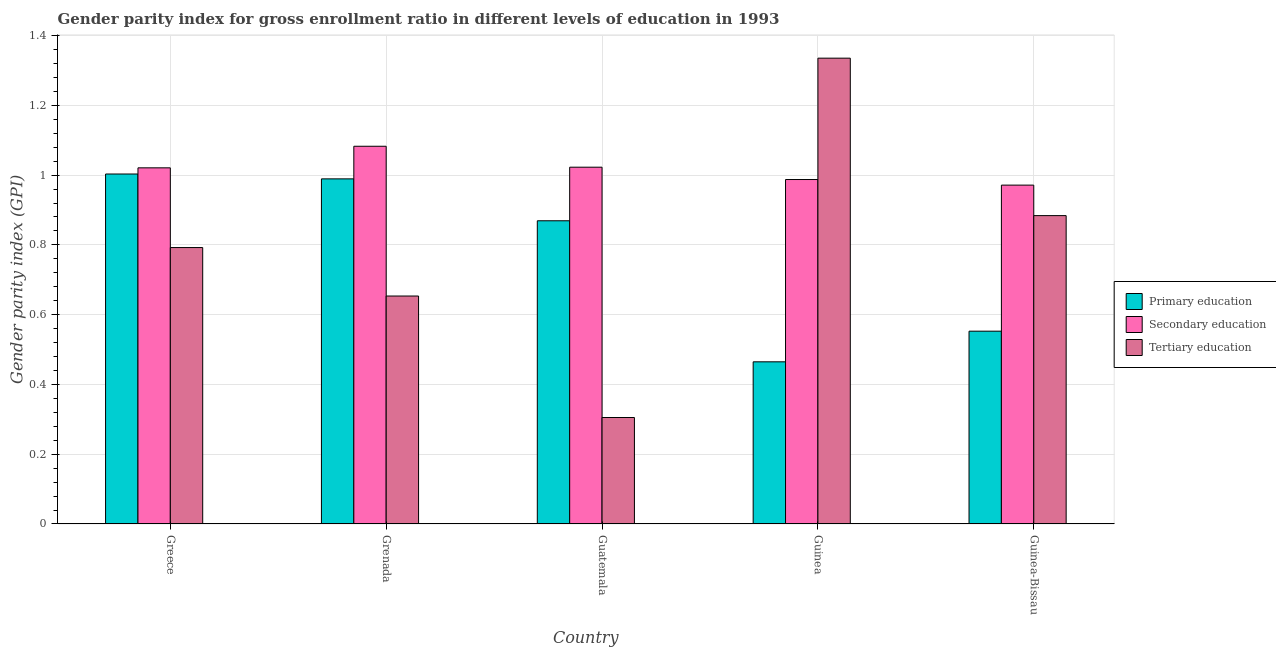Are the number of bars per tick equal to the number of legend labels?
Provide a succinct answer. Yes. Are the number of bars on each tick of the X-axis equal?
Ensure brevity in your answer.  Yes. How many bars are there on the 5th tick from the left?
Your answer should be compact. 3. How many bars are there on the 1st tick from the right?
Make the answer very short. 3. What is the gender parity index in tertiary education in Guinea?
Offer a very short reply. 1.34. Across all countries, what is the maximum gender parity index in tertiary education?
Offer a very short reply. 1.34. Across all countries, what is the minimum gender parity index in primary education?
Offer a terse response. 0.46. In which country was the gender parity index in secondary education maximum?
Provide a short and direct response. Grenada. In which country was the gender parity index in tertiary education minimum?
Offer a terse response. Guatemala. What is the total gender parity index in secondary education in the graph?
Ensure brevity in your answer.  5.08. What is the difference between the gender parity index in tertiary education in Grenada and that in Guinea-Bissau?
Your answer should be very brief. -0.23. What is the difference between the gender parity index in tertiary education in Guinea-Bissau and the gender parity index in primary education in Guinea?
Provide a short and direct response. 0.42. What is the average gender parity index in primary education per country?
Your answer should be compact. 0.78. What is the difference between the gender parity index in secondary education and gender parity index in primary education in Grenada?
Provide a short and direct response. 0.09. In how many countries, is the gender parity index in secondary education greater than 0.92 ?
Your response must be concise. 5. What is the ratio of the gender parity index in secondary education in Guatemala to that in Guinea-Bissau?
Provide a short and direct response. 1.05. Is the difference between the gender parity index in secondary education in Guatemala and Guinea-Bissau greater than the difference between the gender parity index in tertiary education in Guatemala and Guinea-Bissau?
Your answer should be compact. Yes. What is the difference between the highest and the second highest gender parity index in secondary education?
Your answer should be very brief. 0.06. What is the difference between the highest and the lowest gender parity index in secondary education?
Provide a short and direct response. 0.11. Is the sum of the gender parity index in tertiary education in Grenada and Guinea greater than the maximum gender parity index in secondary education across all countries?
Provide a short and direct response. Yes. What does the 2nd bar from the left in Guinea represents?
Ensure brevity in your answer.  Secondary education. What does the 1st bar from the right in Guinea represents?
Give a very brief answer. Tertiary education. Is it the case that in every country, the sum of the gender parity index in primary education and gender parity index in secondary education is greater than the gender parity index in tertiary education?
Provide a succinct answer. Yes. How many bars are there?
Offer a terse response. 15. How many countries are there in the graph?
Ensure brevity in your answer.  5. What is the difference between two consecutive major ticks on the Y-axis?
Provide a short and direct response. 0.2. Are the values on the major ticks of Y-axis written in scientific E-notation?
Your response must be concise. No. Does the graph contain grids?
Your answer should be very brief. Yes. How many legend labels are there?
Provide a succinct answer. 3. How are the legend labels stacked?
Provide a succinct answer. Vertical. What is the title of the graph?
Provide a short and direct response. Gender parity index for gross enrollment ratio in different levels of education in 1993. Does "Maunufacturing" appear as one of the legend labels in the graph?
Ensure brevity in your answer.  No. What is the label or title of the X-axis?
Your response must be concise. Country. What is the label or title of the Y-axis?
Provide a succinct answer. Gender parity index (GPI). What is the Gender parity index (GPI) of Primary education in Greece?
Your response must be concise. 1. What is the Gender parity index (GPI) in Secondary education in Greece?
Provide a short and direct response. 1.02. What is the Gender parity index (GPI) in Tertiary education in Greece?
Your response must be concise. 0.79. What is the Gender parity index (GPI) in Primary education in Grenada?
Provide a short and direct response. 0.99. What is the Gender parity index (GPI) in Secondary education in Grenada?
Your answer should be compact. 1.08. What is the Gender parity index (GPI) in Tertiary education in Grenada?
Offer a very short reply. 0.65. What is the Gender parity index (GPI) in Primary education in Guatemala?
Your answer should be very brief. 0.87. What is the Gender parity index (GPI) of Secondary education in Guatemala?
Provide a succinct answer. 1.02. What is the Gender parity index (GPI) of Tertiary education in Guatemala?
Keep it short and to the point. 0.31. What is the Gender parity index (GPI) of Primary education in Guinea?
Your answer should be very brief. 0.46. What is the Gender parity index (GPI) in Secondary education in Guinea?
Your answer should be very brief. 0.99. What is the Gender parity index (GPI) of Tertiary education in Guinea?
Give a very brief answer. 1.34. What is the Gender parity index (GPI) in Primary education in Guinea-Bissau?
Provide a short and direct response. 0.55. What is the Gender parity index (GPI) of Secondary education in Guinea-Bissau?
Offer a terse response. 0.97. What is the Gender parity index (GPI) in Tertiary education in Guinea-Bissau?
Provide a short and direct response. 0.88. Across all countries, what is the maximum Gender parity index (GPI) in Primary education?
Provide a succinct answer. 1. Across all countries, what is the maximum Gender parity index (GPI) in Secondary education?
Ensure brevity in your answer.  1.08. Across all countries, what is the maximum Gender parity index (GPI) of Tertiary education?
Offer a very short reply. 1.34. Across all countries, what is the minimum Gender parity index (GPI) of Primary education?
Ensure brevity in your answer.  0.46. Across all countries, what is the minimum Gender parity index (GPI) of Secondary education?
Provide a short and direct response. 0.97. Across all countries, what is the minimum Gender parity index (GPI) in Tertiary education?
Keep it short and to the point. 0.31. What is the total Gender parity index (GPI) of Primary education in the graph?
Your response must be concise. 3.88. What is the total Gender parity index (GPI) in Secondary education in the graph?
Ensure brevity in your answer.  5.08. What is the total Gender parity index (GPI) in Tertiary education in the graph?
Offer a very short reply. 3.97. What is the difference between the Gender parity index (GPI) of Primary education in Greece and that in Grenada?
Provide a short and direct response. 0.01. What is the difference between the Gender parity index (GPI) in Secondary education in Greece and that in Grenada?
Provide a succinct answer. -0.06. What is the difference between the Gender parity index (GPI) in Tertiary education in Greece and that in Grenada?
Keep it short and to the point. 0.14. What is the difference between the Gender parity index (GPI) of Primary education in Greece and that in Guatemala?
Make the answer very short. 0.13. What is the difference between the Gender parity index (GPI) in Secondary education in Greece and that in Guatemala?
Your response must be concise. -0. What is the difference between the Gender parity index (GPI) in Tertiary education in Greece and that in Guatemala?
Offer a very short reply. 0.49. What is the difference between the Gender parity index (GPI) in Primary education in Greece and that in Guinea?
Keep it short and to the point. 0.54. What is the difference between the Gender parity index (GPI) in Secondary education in Greece and that in Guinea?
Offer a terse response. 0.03. What is the difference between the Gender parity index (GPI) of Tertiary education in Greece and that in Guinea?
Your answer should be compact. -0.54. What is the difference between the Gender parity index (GPI) in Primary education in Greece and that in Guinea-Bissau?
Your response must be concise. 0.45. What is the difference between the Gender parity index (GPI) of Secondary education in Greece and that in Guinea-Bissau?
Keep it short and to the point. 0.05. What is the difference between the Gender parity index (GPI) of Tertiary education in Greece and that in Guinea-Bissau?
Your answer should be compact. -0.09. What is the difference between the Gender parity index (GPI) of Primary education in Grenada and that in Guatemala?
Make the answer very short. 0.12. What is the difference between the Gender parity index (GPI) in Tertiary education in Grenada and that in Guatemala?
Ensure brevity in your answer.  0.35. What is the difference between the Gender parity index (GPI) in Primary education in Grenada and that in Guinea?
Your response must be concise. 0.52. What is the difference between the Gender parity index (GPI) in Secondary education in Grenada and that in Guinea?
Provide a short and direct response. 0.1. What is the difference between the Gender parity index (GPI) of Tertiary education in Grenada and that in Guinea?
Your answer should be compact. -0.68. What is the difference between the Gender parity index (GPI) in Primary education in Grenada and that in Guinea-Bissau?
Your response must be concise. 0.44. What is the difference between the Gender parity index (GPI) in Secondary education in Grenada and that in Guinea-Bissau?
Make the answer very short. 0.11. What is the difference between the Gender parity index (GPI) in Tertiary education in Grenada and that in Guinea-Bissau?
Ensure brevity in your answer.  -0.23. What is the difference between the Gender parity index (GPI) of Primary education in Guatemala and that in Guinea?
Provide a short and direct response. 0.4. What is the difference between the Gender parity index (GPI) of Secondary education in Guatemala and that in Guinea?
Provide a short and direct response. 0.04. What is the difference between the Gender parity index (GPI) in Tertiary education in Guatemala and that in Guinea?
Offer a very short reply. -1.03. What is the difference between the Gender parity index (GPI) in Primary education in Guatemala and that in Guinea-Bissau?
Your answer should be very brief. 0.32. What is the difference between the Gender parity index (GPI) of Secondary education in Guatemala and that in Guinea-Bissau?
Your answer should be very brief. 0.05. What is the difference between the Gender parity index (GPI) in Tertiary education in Guatemala and that in Guinea-Bissau?
Give a very brief answer. -0.58. What is the difference between the Gender parity index (GPI) in Primary education in Guinea and that in Guinea-Bissau?
Ensure brevity in your answer.  -0.09. What is the difference between the Gender parity index (GPI) in Secondary education in Guinea and that in Guinea-Bissau?
Offer a very short reply. 0.02. What is the difference between the Gender parity index (GPI) of Tertiary education in Guinea and that in Guinea-Bissau?
Your answer should be very brief. 0.45. What is the difference between the Gender parity index (GPI) in Primary education in Greece and the Gender parity index (GPI) in Secondary education in Grenada?
Make the answer very short. -0.08. What is the difference between the Gender parity index (GPI) of Primary education in Greece and the Gender parity index (GPI) of Tertiary education in Grenada?
Make the answer very short. 0.35. What is the difference between the Gender parity index (GPI) of Secondary education in Greece and the Gender parity index (GPI) of Tertiary education in Grenada?
Your response must be concise. 0.37. What is the difference between the Gender parity index (GPI) of Primary education in Greece and the Gender parity index (GPI) of Secondary education in Guatemala?
Your answer should be very brief. -0.02. What is the difference between the Gender parity index (GPI) in Primary education in Greece and the Gender parity index (GPI) in Tertiary education in Guatemala?
Your answer should be compact. 0.7. What is the difference between the Gender parity index (GPI) of Secondary education in Greece and the Gender parity index (GPI) of Tertiary education in Guatemala?
Keep it short and to the point. 0.72. What is the difference between the Gender parity index (GPI) of Primary education in Greece and the Gender parity index (GPI) of Secondary education in Guinea?
Offer a very short reply. 0.02. What is the difference between the Gender parity index (GPI) in Primary education in Greece and the Gender parity index (GPI) in Tertiary education in Guinea?
Your response must be concise. -0.33. What is the difference between the Gender parity index (GPI) in Secondary education in Greece and the Gender parity index (GPI) in Tertiary education in Guinea?
Provide a succinct answer. -0.31. What is the difference between the Gender parity index (GPI) in Primary education in Greece and the Gender parity index (GPI) in Secondary education in Guinea-Bissau?
Provide a succinct answer. 0.03. What is the difference between the Gender parity index (GPI) of Primary education in Greece and the Gender parity index (GPI) of Tertiary education in Guinea-Bissau?
Your answer should be compact. 0.12. What is the difference between the Gender parity index (GPI) in Secondary education in Greece and the Gender parity index (GPI) in Tertiary education in Guinea-Bissau?
Your answer should be very brief. 0.14. What is the difference between the Gender parity index (GPI) in Primary education in Grenada and the Gender parity index (GPI) in Secondary education in Guatemala?
Offer a terse response. -0.03. What is the difference between the Gender parity index (GPI) in Primary education in Grenada and the Gender parity index (GPI) in Tertiary education in Guatemala?
Provide a short and direct response. 0.68. What is the difference between the Gender parity index (GPI) of Secondary education in Grenada and the Gender parity index (GPI) of Tertiary education in Guatemala?
Offer a terse response. 0.78. What is the difference between the Gender parity index (GPI) in Primary education in Grenada and the Gender parity index (GPI) in Secondary education in Guinea?
Keep it short and to the point. 0. What is the difference between the Gender parity index (GPI) of Primary education in Grenada and the Gender parity index (GPI) of Tertiary education in Guinea?
Provide a succinct answer. -0.35. What is the difference between the Gender parity index (GPI) in Secondary education in Grenada and the Gender parity index (GPI) in Tertiary education in Guinea?
Your answer should be very brief. -0.25. What is the difference between the Gender parity index (GPI) of Primary education in Grenada and the Gender parity index (GPI) of Secondary education in Guinea-Bissau?
Your response must be concise. 0.02. What is the difference between the Gender parity index (GPI) in Primary education in Grenada and the Gender parity index (GPI) in Tertiary education in Guinea-Bissau?
Make the answer very short. 0.11. What is the difference between the Gender parity index (GPI) in Secondary education in Grenada and the Gender parity index (GPI) in Tertiary education in Guinea-Bissau?
Keep it short and to the point. 0.2. What is the difference between the Gender parity index (GPI) of Primary education in Guatemala and the Gender parity index (GPI) of Secondary education in Guinea?
Give a very brief answer. -0.12. What is the difference between the Gender parity index (GPI) in Primary education in Guatemala and the Gender parity index (GPI) in Tertiary education in Guinea?
Offer a very short reply. -0.47. What is the difference between the Gender parity index (GPI) of Secondary education in Guatemala and the Gender parity index (GPI) of Tertiary education in Guinea?
Your answer should be very brief. -0.31. What is the difference between the Gender parity index (GPI) in Primary education in Guatemala and the Gender parity index (GPI) in Secondary education in Guinea-Bissau?
Ensure brevity in your answer.  -0.1. What is the difference between the Gender parity index (GPI) in Primary education in Guatemala and the Gender parity index (GPI) in Tertiary education in Guinea-Bissau?
Offer a terse response. -0.01. What is the difference between the Gender parity index (GPI) of Secondary education in Guatemala and the Gender parity index (GPI) of Tertiary education in Guinea-Bissau?
Your answer should be very brief. 0.14. What is the difference between the Gender parity index (GPI) of Primary education in Guinea and the Gender parity index (GPI) of Secondary education in Guinea-Bissau?
Make the answer very short. -0.51. What is the difference between the Gender parity index (GPI) of Primary education in Guinea and the Gender parity index (GPI) of Tertiary education in Guinea-Bissau?
Keep it short and to the point. -0.42. What is the difference between the Gender parity index (GPI) in Secondary education in Guinea and the Gender parity index (GPI) in Tertiary education in Guinea-Bissau?
Make the answer very short. 0.1. What is the average Gender parity index (GPI) in Primary education per country?
Offer a very short reply. 0.78. What is the average Gender parity index (GPI) in Tertiary education per country?
Provide a succinct answer. 0.79. What is the difference between the Gender parity index (GPI) in Primary education and Gender parity index (GPI) in Secondary education in Greece?
Provide a succinct answer. -0.02. What is the difference between the Gender parity index (GPI) in Primary education and Gender parity index (GPI) in Tertiary education in Greece?
Your answer should be compact. 0.21. What is the difference between the Gender parity index (GPI) of Secondary education and Gender parity index (GPI) of Tertiary education in Greece?
Your response must be concise. 0.23. What is the difference between the Gender parity index (GPI) of Primary education and Gender parity index (GPI) of Secondary education in Grenada?
Provide a succinct answer. -0.09. What is the difference between the Gender parity index (GPI) of Primary education and Gender parity index (GPI) of Tertiary education in Grenada?
Your response must be concise. 0.34. What is the difference between the Gender parity index (GPI) in Secondary education and Gender parity index (GPI) in Tertiary education in Grenada?
Ensure brevity in your answer.  0.43. What is the difference between the Gender parity index (GPI) in Primary education and Gender parity index (GPI) in Secondary education in Guatemala?
Provide a succinct answer. -0.15. What is the difference between the Gender parity index (GPI) in Primary education and Gender parity index (GPI) in Tertiary education in Guatemala?
Ensure brevity in your answer.  0.56. What is the difference between the Gender parity index (GPI) in Secondary education and Gender parity index (GPI) in Tertiary education in Guatemala?
Your answer should be very brief. 0.72. What is the difference between the Gender parity index (GPI) of Primary education and Gender parity index (GPI) of Secondary education in Guinea?
Your answer should be compact. -0.52. What is the difference between the Gender parity index (GPI) of Primary education and Gender parity index (GPI) of Tertiary education in Guinea?
Your response must be concise. -0.87. What is the difference between the Gender parity index (GPI) of Secondary education and Gender parity index (GPI) of Tertiary education in Guinea?
Offer a terse response. -0.35. What is the difference between the Gender parity index (GPI) of Primary education and Gender parity index (GPI) of Secondary education in Guinea-Bissau?
Your response must be concise. -0.42. What is the difference between the Gender parity index (GPI) of Primary education and Gender parity index (GPI) of Tertiary education in Guinea-Bissau?
Your answer should be compact. -0.33. What is the difference between the Gender parity index (GPI) of Secondary education and Gender parity index (GPI) of Tertiary education in Guinea-Bissau?
Make the answer very short. 0.09. What is the ratio of the Gender parity index (GPI) in Primary education in Greece to that in Grenada?
Offer a terse response. 1.01. What is the ratio of the Gender parity index (GPI) in Secondary education in Greece to that in Grenada?
Ensure brevity in your answer.  0.94. What is the ratio of the Gender parity index (GPI) of Tertiary education in Greece to that in Grenada?
Ensure brevity in your answer.  1.21. What is the ratio of the Gender parity index (GPI) in Primary education in Greece to that in Guatemala?
Offer a very short reply. 1.15. What is the ratio of the Gender parity index (GPI) of Tertiary education in Greece to that in Guatemala?
Your answer should be compact. 2.6. What is the ratio of the Gender parity index (GPI) in Primary education in Greece to that in Guinea?
Provide a short and direct response. 2.16. What is the ratio of the Gender parity index (GPI) of Secondary education in Greece to that in Guinea?
Your answer should be very brief. 1.03. What is the ratio of the Gender parity index (GPI) of Tertiary education in Greece to that in Guinea?
Provide a succinct answer. 0.59. What is the ratio of the Gender parity index (GPI) of Primary education in Greece to that in Guinea-Bissau?
Your answer should be very brief. 1.82. What is the ratio of the Gender parity index (GPI) of Secondary education in Greece to that in Guinea-Bissau?
Keep it short and to the point. 1.05. What is the ratio of the Gender parity index (GPI) in Tertiary education in Greece to that in Guinea-Bissau?
Your answer should be very brief. 0.9. What is the ratio of the Gender parity index (GPI) of Primary education in Grenada to that in Guatemala?
Your answer should be compact. 1.14. What is the ratio of the Gender parity index (GPI) of Secondary education in Grenada to that in Guatemala?
Keep it short and to the point. 1.06. What is the ratio of the Gender parity index (GPI) of Tertiary education in Grenada to that in Guatemala?
Keep it short and to the point. 2.14. What is the ratio of the Gender parity index (GPI) in Primary education in Grenada to that in Guinea?
Your answer should be very brief. 2.13. What is the ratio of the Gender parity index (GPI) in Secondary education in Grenada to that in Guinea?
Your response must be concise. 1.1. What is the ratio of the Gender parity index (GPI) of Tertiary education in Grenada to that in Guinea?
Offer a very short reply. 0.49. What is the ratio of the Gender parity index (GPI) of Primary education in Grenada to that in Guinea-Bissau?
Offer a terse response. 1.79. What is the ratio of the Gender parity index (GPI) of Secondary education in Grenada to that in Guinea-Bissau?
Offer a terse response. 1.11. What is the ratio of the Gender parity index (GPI) of Tertiary education in Grenada to that in Guinea-Bissau?
Ensure brevity in your answer.  0.74. What is the ratio of the Gender parity index (GPI) of Primary education in Guatemala to that in Guinea?
Your answer should be very brief. 1.87. What is the ratio of the Gender parity index (GPI) of Secondary education in Guatemala to that in Guinea?
Your answer should be compact. 1.04. What is the ratio of the Gender parity index (GPI) of Tertiary education in Guatemala to that in Guinea?
Provide a succinct answer. 0.23. What is the ratio of the Gender parity index (GPI) in Primary education in Guatemala to that in Guinea-Bissau?
Your response must be concise. 1.57. What is the ratio of the Gender parity index (GPI) in Secondary education in Guatemala to that in Guinea-Bissau?
Your answer should be very brief. 1.05. What is the ratio of the Gender parity index (GPI) in Tertiary education in Guatemala to that in Guinea-Bissau?
Give a very brief answer. 0.35. What is the ratio of the Gender parity index (GPI) in Primary education in Guinea to that in Guinea-Bissau?
Offer a terse response. 0.84. What is the ratio of the Gender parity index (GPI) in Secondary education in Guinea to that in Guinea-Bissau?
Your answer should be very brief. 1.02. What is the ratio of the Gender parity index (GPI) in Tertiary education in Guinea to that in Guinea-Bissau?
Ensure brevity in your answer.  1.51. What is the difference between the highest and the second highest Gender parity index (GPI) in Primary education?
Make the answer very short. 0.01. What is the difference between the highest and the second highest Gender parity index (GPI) in Tertiary education?
Offer a terse response. 0.45. What is the difference between the highest and the lowest Gender parity index (GPI) in Primary education?
Your response must be concise. 0.54. What is the difference between the highest and the lowest Gender parity index (GPI) in Secondary education?
Keep it short and to the point. 0.11. What is the difference between the highest and the lowest Gender parity index (GPI) of Tertiary education?
Offer a terse response. 1.03. 